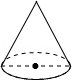What might be the purpose of the markings around the base of the cone? The markings around the base of the cone likely serve as a scale or reference points to measure the circumference or to divide it into equal segments for various educational or practical applications. 